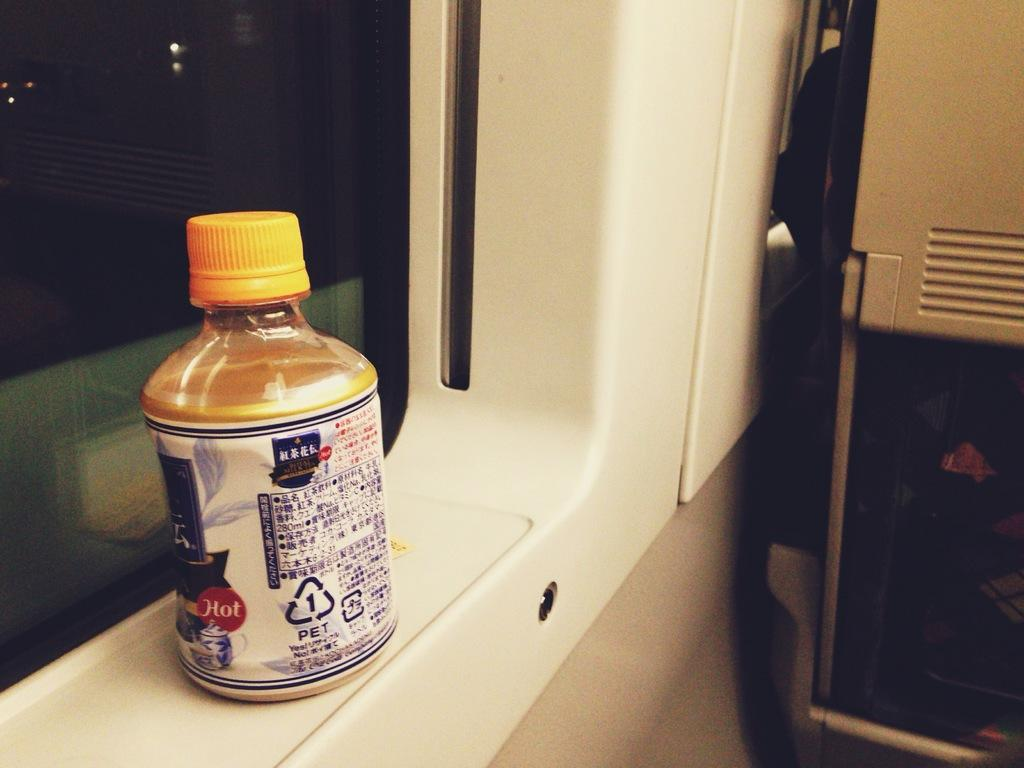What object can be seen in the image? There is a bottle in the image. Where is the bottle placed in relation to other elements in the image? The bottle is kept in front of a window. What other object is near the window in the image? There is a seat beside the window in the image. What type of wheel can be seen attached to the carriage in the image? There is no carriage or wheel present in the image; it only features a bottle and a window with a seat beside it. 